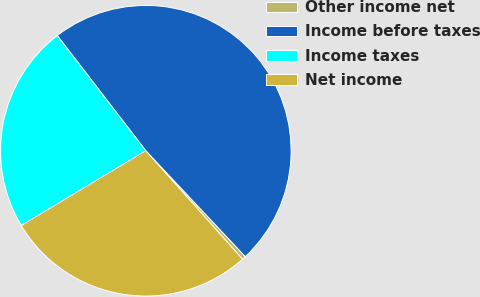<chart> <loc_0><loc_0><loc_500><loc_500><pie_chart><fcel>Other income net<fcel>Income before taxes<fcel>Income taxes<fcel>Net income<nl><fcel>0.41%<fcel>48.43%<fcel>23.18%<fcel>27.98%<nl></chart> 